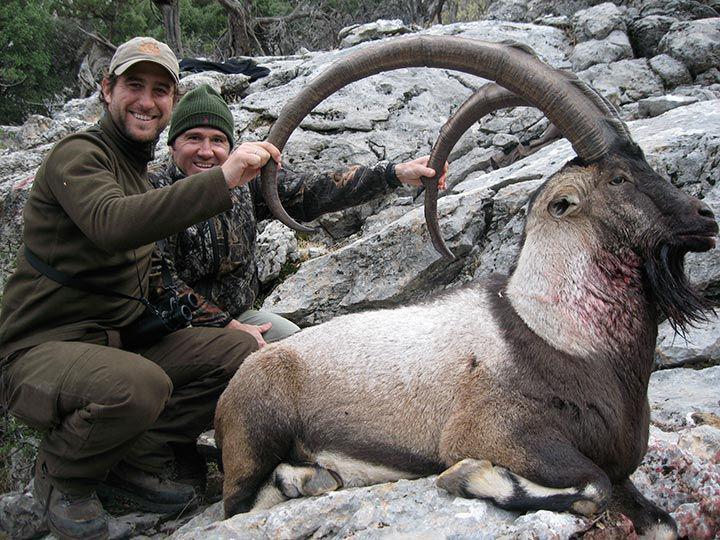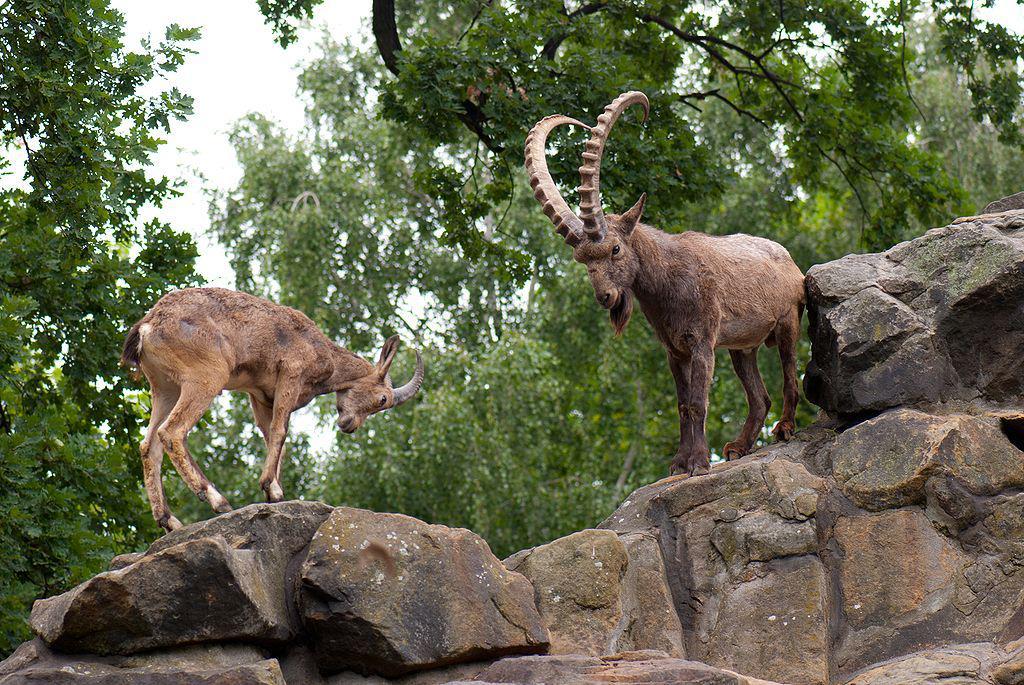The first image is the image on the left, the second image is the image on the right. For the images displayed, is the sentence "Horned rams in the  pair of images are facing toward each other." factually correct? Answer yes or no. Yes. 